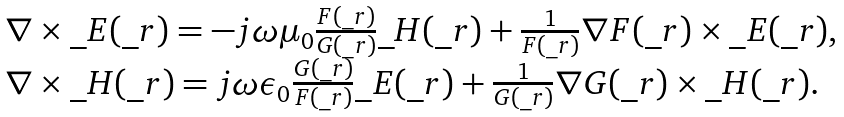Convert formula to latex. <formula><loc_0><loc_0><loc_500><loc_500>\begin{array} { l } \nabla \times \_ E ( \_ r ) = - j \omega \mu _ { 0 } \frac { F ( \_ r ) } { G ( \_ r ) } \_ H ( \_ r ) + \frac { 1 } { F ( \_ r ) } \nabla F ( \_ r ) \times \_ E ( \_ r ) , \\ \nabla \times \_ H ( \_ r ) = j \omega \epsilon _ { 0 } \frac { G ( \_ r ) } { F ( \_ r ) } \_ E ( \_ r ) + \frac { 1 } { G ( \_ r ) } \nabla G ( \_ r ) \times \_ H ( \_ r ) . \end{array}</formula> 